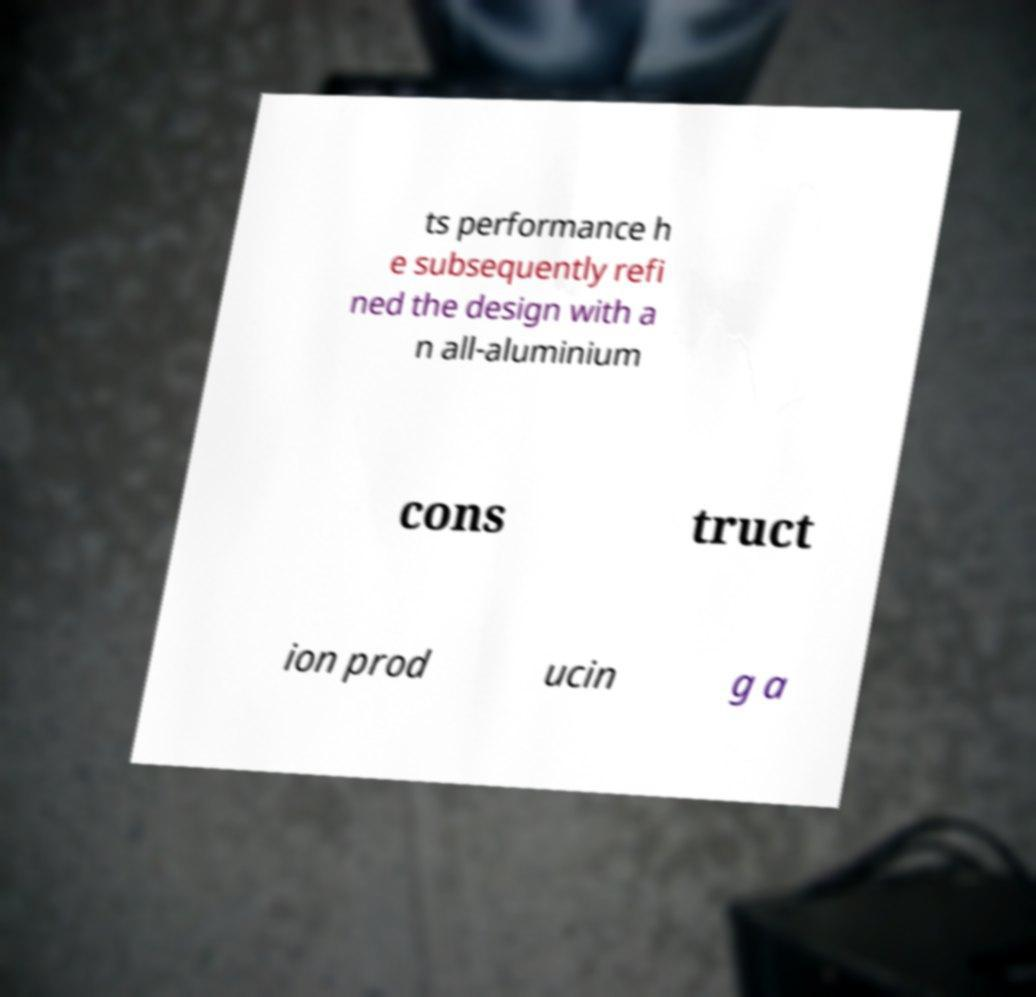Could you extract and type out the text from this image? ts performance h e subsequently refi ned the design with a n all-aluminium cons truct ion prod ucin g a 